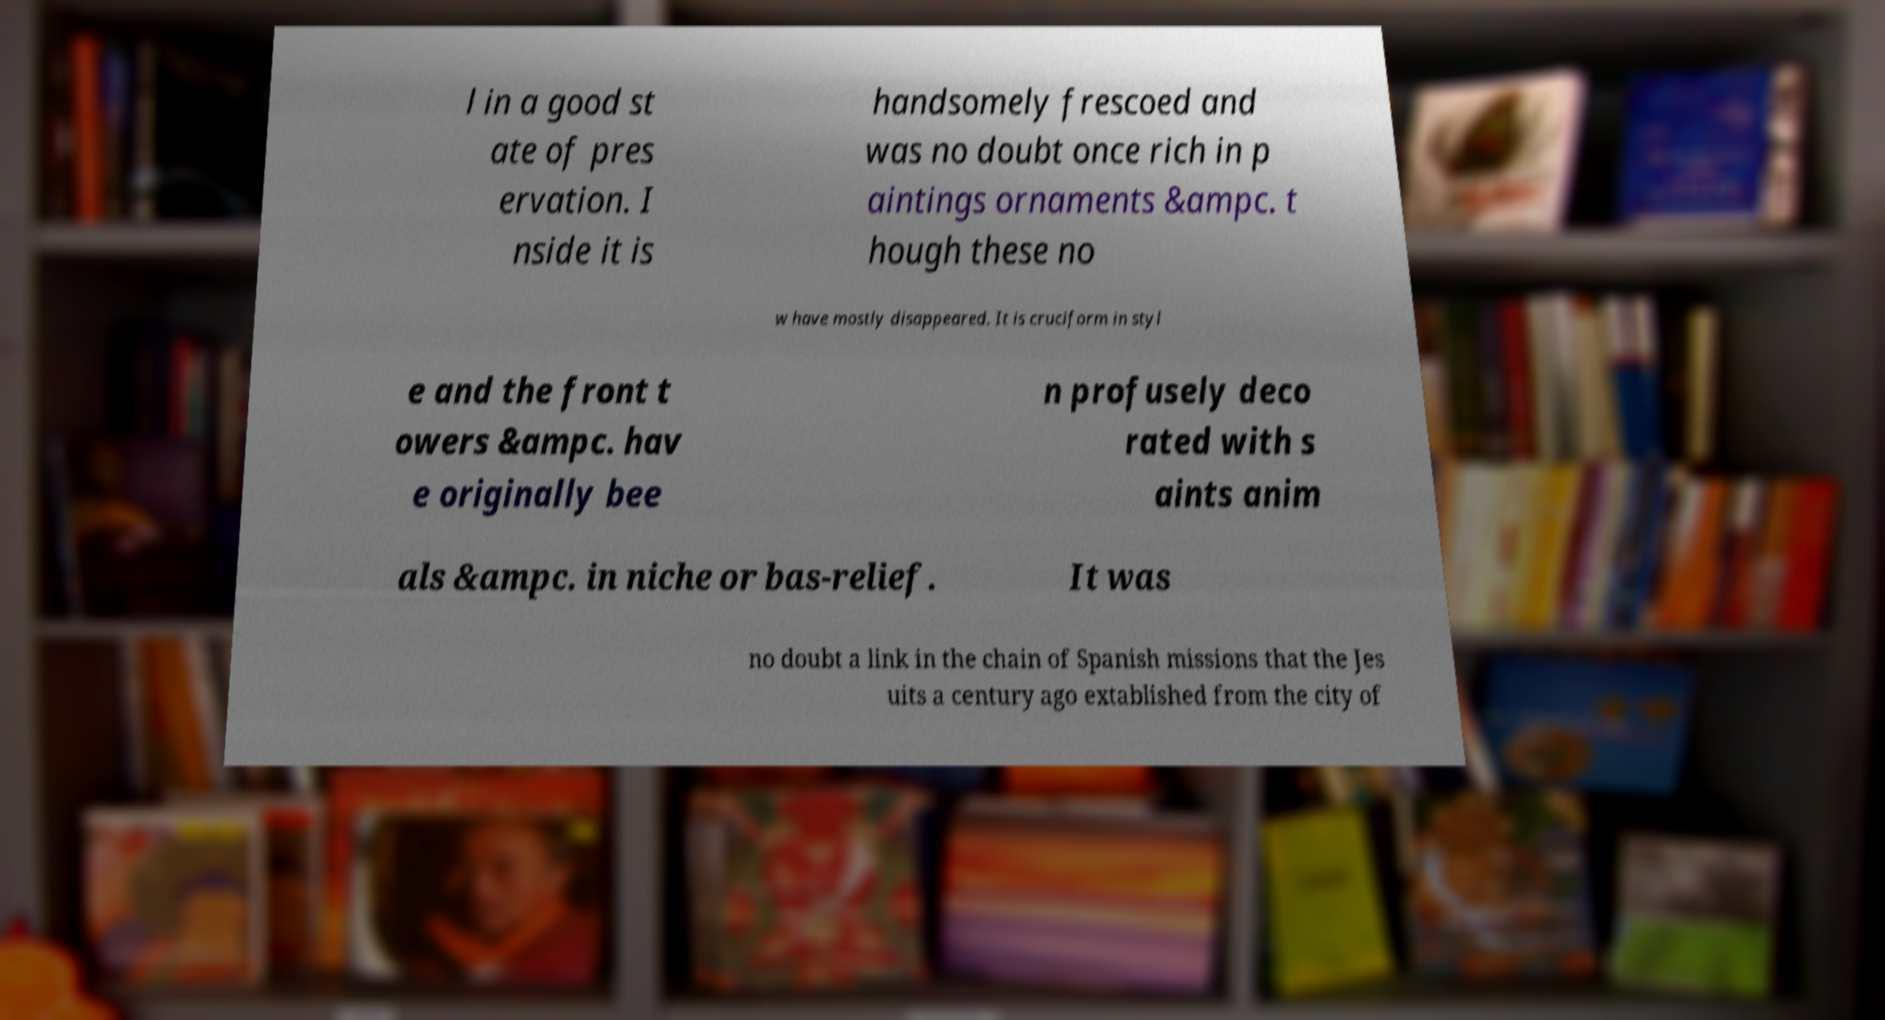Could you assist in decoding the text presented in this image and type it out clearly? l in a good st ate of pres ervation. I nside it is handsomely frescoed and was no doubt once rich in p aintings ornaments &ampc. t hough these no w have mostly disappeared. It is cruciform in styl e and the front t owers &ampc. hav e originally bee n profusely deco rated with s aints anim als &ampc. in niche or bas-relief. It was no doubt a link in the chain of Spanish missions that the Jes uits a century ago extablished from the city of 